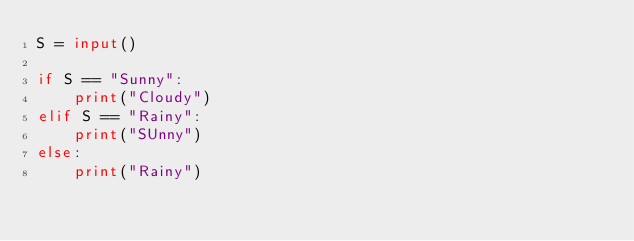<code> <loc_0><loc_0><loc_500><loc_500><_Python_>S = input()

if S == "Sunny":
    print("Cloudy")
elif S == "Rainy":
    print("SUnny")
else:
    print("Rainy")
</code> 